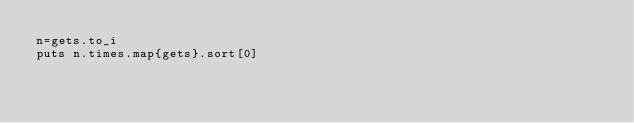Convert code to text. <code><loc_0><loc_0><loc_500><loc_500><_Ruby_>n=gets.to_i
puts n.times.map{gets}.sort[0]</code> 